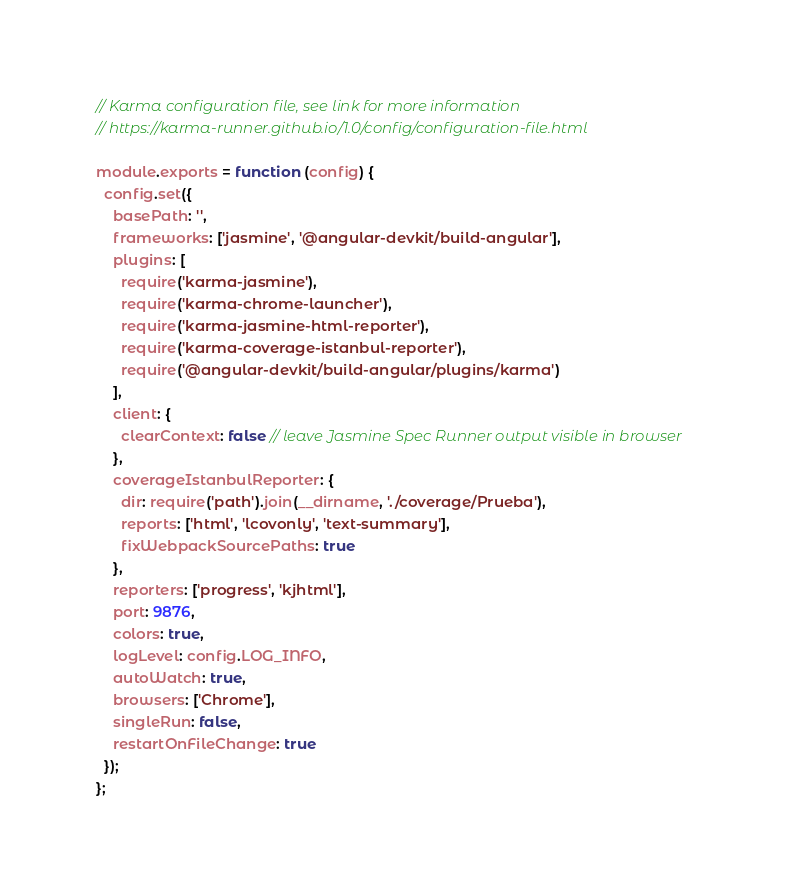Convert code to text. <code><loc_0><loc_0><loc_500><loc_500><_JavaScript_>// Karma configuration file, see link for more information
// https://karma-runner.github.io/1.0/config/configuration-file.html

module.exports = function (config) {
  config.set({
    basePath: '',
    frameworks: ['jasmine', '@angular-devkit/build-angular'],
    plugins: [
      require('karma-jasmine'),
      require('karma-chrome-launcher'),
      require('karma-jasmine-html-reporter'),
      require('karma-coverage-istanbul-reporter'),
      require('@angular-devkit/build-angular/plugins/karma')
    ],
    client: {
      clearContext: false // leave Jasmine Spec Runner output visible in browser
    },
    coverageIstanbulReporter: {
      dir: require('path').join(__dirname, './coverage/Prueba'),
      reports: ['html', 'lcovonly', 'text-summary'],
      fixWebpackSourcePaths: true
    },
    reporters: ['progress', 'kjhtml'],
    port: 9876,
    colors: true,
    logLevel: config.LOG_INFO,
    autoWatch: true,
    browsers: ['Chrome'],
    singleRun: false,
    restartOnFileChange: true
  });
};
</code> 